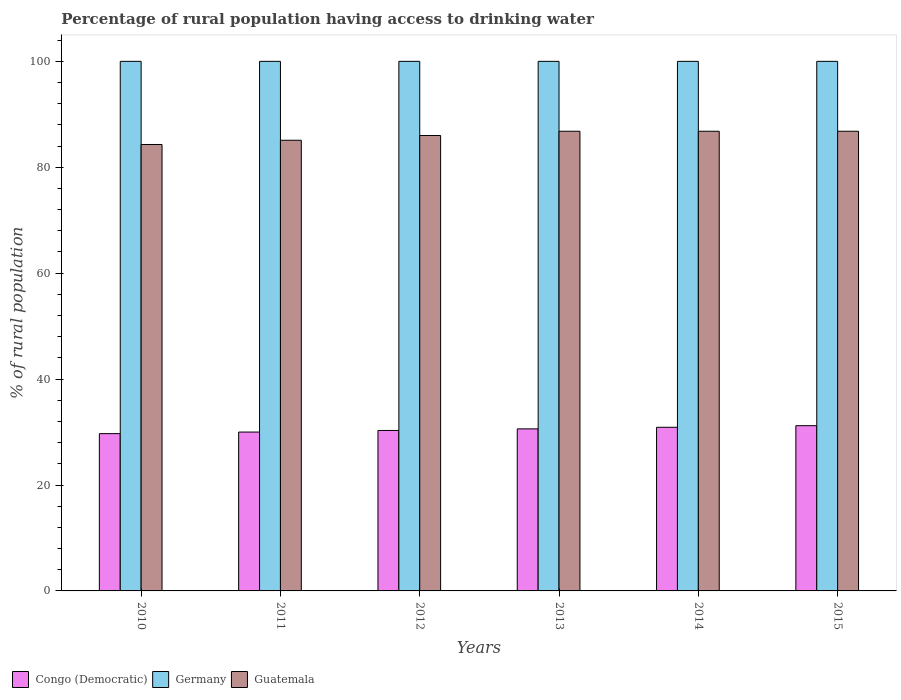How many groups of bars are there?
Your answer should be compact. 6. How many bars are there on the 5th tick from the left?
Keep it short and to the point. 3. In how many cases, is the number of bars for a given year not equal to the number of legend labels?
Keep it short and to the point. 0. Across all years, what is the maximum percentage of rural population having access to drinking water in Guatemala?
Offer a terse response. 86.8. Across all years, what is the minimum percentage of rural population having access to drinking water in Congo (Democratic)?
Give a very brief answer. 29.7. In which year was the percentage of rural population having access to drinking water in Germany maximum?
Your answer should be compact. 2010. What is the total percentage of rural population having access to drinking water in Germany in the graph?
Your answer should be compact. 600. What is the difference between the percentage of rural population having access to drinking water in Germany in 2014 and that in 2015?
Keep it short and to the point. 0. What is the difference between the percentage of rural population having access to drinking water in Guatemala in 2014 and the percentage of rural population having access to drinking water in Congo (Democratic) in 2012?
Your answer should be very brief. 56.5. What is the average percentage of rural population having access to drinking water in Guatemala per year?
Ensure brevity in your answer.  85.97. In the year 2012, what is the difference between the percentage of rural population having access to drinking water in Congo (Democratic) and percentage of rural population having access to drinking water in Germany?
Keep it short and to the point. -69.7. What is the ratio of the percentage of rural population having access to drinking water in Guatemala in 2011 to that in 2014?
Ensure brevity in your answer.  0.98. Is the percentage of rural population having access to drinking water in Germany in 2010 less than that in 2012?
Provide a succinct answer. No. Is the difference between the percentage of rural population having access to drinking water in Congo (Democratic) in 2013 and 2014 greater than the difference between the percentage of rural population having access to drinking water in Germany in 2013 and 2014?
Your response must be concise. No. What is the difference between the highest and the lowest percentage of rural population having access to drinking water in Congo (Democratic)?
Offer a terse response. 1.5. What does the 1st bar from the left in 2015 represents?
Give a very brief answer. Congo (Democratic). Is it the case that in every year, the sum of the percentage of rural population having access to drinking water in Germany and percentage of rural population having access to drinking water in Congo (Democratic) is greater than the percentage of rural population having access to drinking water in Guatemala?
Give a very brief answer. Yes. Are all the bars in the graph horizontal?
Give a very brief answer. No. What is the difference between two consecutive major ticks on the Y-axis?
Give a very brief answer. 20. Are the values on the major ticks of Y-axis written in scientific E-notation?
Provide a succinct answer. No. Where does the legend appear in the graph?
Provide a short and direct response. Bottom left. How many legend labels are there?
Ensure brevity in your answer.  3. What is the title of the graph?
Your answer should be very brief. Percentage of rural population having access to drinking water. What is the label or title of the X-axis?
Offer a terse response. Years. What is the label or title of the Y-axis?
Offer a very short reply. % of rural population. What is the % of rural population of Congo (Democratic) in 2010?
Your answer should be compact. 29.7. What is the % of rural population in Guatemala in 2010?
Ensure brevity in your answer.  84.3. What is the % of rural population of Germany in 2011?
Ensure brevity in your answer.  100. What is the % of rural population in Guatemala in 2011?
Give a very brief answer. 85.1. What is the % of rural population in Congo (Democratic) in 2012?
Ensure brevity in your answer.  30.3. What is the % of rural population of Germany in 2012?
Your answer should be very brief. 100. What is the % of rural population of Congo (Democratic) in 2013?
Your response must be concise. 30.6. What is the % of rural population of Germany in 2013?
Provide a short and direct response. 100. What is the % of rural population in Guatemala in 2013?
Provide a succinct answer. 86.8. What is the % of rural population of Congo (Democratic) in 2014?
Provide a succinct answer. 30.9. What is the % of rural population of Germany in 2014?
Offer a terse response. 100. What is the % of rural population of Guatemala in 2014?
Provide a succinct answer. 86.8. What is the % of rural population in Congo (Democratic) in 2015?
Offer a terse response. 31.2. What is the % of rural population of Guatemala in 2015?
Your answer should be very brief. 86.8. Across all years, what is the maximum % of rural population of Congo (Democratic)?
Your response must be concise. 31.2. Across all years, what is the maximum % of rural population of Guatemala?
Provide a short and direct response. 86.8. Across all years, what is the minimum % of rural population of Congo (Democratic)?
Offer a very short reply. 29.7. Across all years, what is the minimum % of rural population of Guatemala?
Your response must be concise. 84.3. What is the total % of rural population in Congo (Democratic) in the graph?
Offer a terse response. 182.7. What is the total % of rural population of Germany in the graph?
Provide a short and direct response. 600. What is the total % of rural population of Guatemala in the graph?
Keep it short and to the point. 515.8. What is the difference between the % of rural population of Germany in 2010 and that in 2011?
Your response must be concise. 0. What is the difference between the % of rural population of Congo (Democratic) in 2010 and that in 2012?
Keep it short and to the point. -0.6. What is the difference between the % of rural population in Germany in 2010 and that in 2012?
Provide a succinct answer. 0. What is the difference between the % of rural population in Guatemala in 2010 and that in 2012?
Your response must be concise. -1.7. What is the difference between the % of rural population of Congo (Democratic) in 2010 and that in 2013?
Provide a succinct answer. -0.9. What is the difference between the % of rural population of Guatemala in 2010 and that in 2013?
Give a very brief answer. -2.5. What is the difference between the % of rural population of Congo (Democratic) in 2010 and that in 2014?
Provide a short and direct response. -1.2. What is the difference between the % of rural population of Germany in 2010 and that in 2014?
Your answer should be compact. 0. What is the difference between the % of rural population in Guatemala in 2010 and that in 2014?
Offer a terse response. -2.5. What is the difference between the % of rural population in Congo (Democratic) in 2010 and that in 2015?
Your response must be concise. -1.5. What is the difference between the % of rural population in Germany in 2011 and that in 2012?
Provide a succinct answer. 0. What is the difference between the % of rural population of Congo (Democratic) in 2011 and that in 2013?
Give a very brief answer. -0.6. What is the difference between the % of rural population in Germany in 2011 and that in 2013?
Your response must be concise. 0. What is the difference between the % of rural population of Guatemala in 2011 and that in 2013?
Your answer should be very brief. -1.7. What is the difference between the % of rural population of Congo (Democratic) in 2011 and that in 2014?
Make the answer very short. -0.9. What is the difference between the % of rural population in Germany in 2011 and that in 2014?
Offer a very short reply. 0. What is the difference between the % of rural population in Guatemala in 2011 and that in 2014?
Provide a short and direct response. -1.7. What is the difference between the % of rural population in Congo (Democratic) in 2012 and that in 2013?
Your answer should be compact. -0.3. What is the difference between the % of rural population of Germany in 2012 and that in 2013?
Give a very brief answer. 0. What is the difference between the % of rural population in Germany in 2012 and that in 2014?
Provide a short and direct response. 0. What is the difference between the % of rural population of Congo (Democratic) in 2012 and that in 2015?
Your response must be concise. -0.9. What is the difference between the % of rural population of Germany in 2012 and that in 2015?
Keep it short and to the point. 0. What is the difference between the % of rural population of Guatemala in 2012 and that in 2015?
Make the answer very short. -0.8. What is the difference between the % of rural population of Congo (Democratic) in 2013 and that in 2014?
Your response must be concise. -0.3. What is the difference between the % of rural population of Germany in 2013 and that in 2014?
Provide a short and direct response. 0. What is the difference between the % of rural population in Guatemala in 2013 and that in 2014?
Your response must be concise. 0. What is the difference between the % of rural population of Germany in 2013 and that in 2015?
Ensure brevity in your answer.  0. What is the difference between the % of rural population of Guatemala in 2013 and that in 2015?
Provide a succinct answer. 0. What is the difference between the % of rural population in Congo (Democratic) in 2014 and that in 2015?
Provide a short and direct response. -0.3. What is the difference between the % of rural population of Guatemala in 2014 and that in 2015?
Make the answer very short. 0. What is the difference between the % of rural population of Congo (Democratic) in 2010 and the % of rural population of Germany in 2011?
Offer a terse response. -70.3. What is the difference between the % of rural population in Congo (Democratic) in 2010 and the % of rural population in Guatemala in 2011?
Keep it short and to the point. -55.4. What is the difference between the % of rural population in Germany in 2010 and the % of rural population in Guatemala in 2011?
Your response must be concise. 14.9. What is the difference between the % of rural population of Congo (Democratic) in 2010 and the % of rural population of Germany in 2012?
Your answer should be compact. -70.3. What is the difference between the % of rural population in Congo (Democratic) in 2010 and the % of rural population in Guatemala in 2012?
Ensure brevity in your answer.  -56.3. What is the difference between the % of rural population of Germany in 2010 and the % of rural population of Guatemala in 2012?
Offer a terse response. 14. What is the difference between the % of rural population in Congo (Democratic) in 2010 and the % of rural population in Germany in 2013?
Make the answer very short. -70.3. What is the difference between the % of rural population in Congo (Democratic) in 2010 and the % of rural population in Guatemala in 2013?
Your response must be concise. -57.1. What is the difference between the % of rural population in Congo (Democratic) in 2010 and the % of rural population in Germany in 2014?
Give a very brief answer. -70.3. What is the difference between the % of rural population in Congo (Democratic) in 2010 and the % of rural population in Guatemala in 2014?
Your answer should be compact. -57.1. What is the difference between the % of rural population in Germany in 2010 and the % of rural population in Guatemala in 2014?
Offer a terse response. 13.2. What is the difference between the % of rural population of Congo (Democratic) in 2010 and the % of rural population of Germany in 2015?
Your response must be concise. -70.3. What is the difference between the % of rural population of Congo (Democratic) in 2010 and the % of rural population of Guatemala in 2015?
Your answer should be very brief. -57.1. What is the difference between the % of rural population in Congo (Democratic) in 2011 and the % of rural population in Germany in 2012?
Keep it short and to the point. -70. What is the difference between the % of rural population in Congo (Democratic) in 2011 and the % of rural population in Guatemala in 2012?
Your answer should be compact. -56. What is the difference between the % of rural population of Germany in 2011 and the % of rural population of Guatemala in 2012?
Keep it short and to the point. 14. What is the difference between the % of rural population in Congo (Democratic) in 2011 and the % of rural population in Germany in 2013?
Provide a succinct answer. -70. What is the difference between the % of rural population of Congo (Democratic) in 2011 and the % of rural population of Guatemala in 2013?
Provide a short and direct response. -56.8. What is the difference between the % of rural population in Germany in 2011 and the % of rural population in Guatemala in 2013?
Your answer should be very brief. 13.2. What is the difference between the % of rural population of Congo (Democratic) in 2011 and the % of rural population of Germany in 2014?
Ensure brevity in your answer.  -70. What is the difference between the % of rural population in Congo (Democratic) in 2011 and the % of rural population in Guatemala in 2014?
Provide a succinct answer. -56.8. What is the difference between the % of rural population of Germany in 2011 and the % of rural population of Guatemala in 2014?
Offer a terse response. 13.2. What is the difference between the % of rural population in Congo (Democratic) in 2011 and the % of rural population in Germany in 2015?
Your answer should be compact. -70. What is the difference between the % of rural population of Congo (Democratic) in 2011 and the % of rural population of Guatemala in 2015?
Your answer should be very brief. -56.8. What is the difference between the % of rural population of Congo (Democratic) in 2012 and the % of rural population of Germany in 2013?
Your response must be concise. -69.7. What is the difference between the % of rural population of Congo (Democratic) in 2012 and the % of rural population of Guatemala in 2013?
Offer a terse response. -56.5. What is the difference between the % of rural population in Congo (Democratic) in 2012 and the % of rural population in Germany in 2014?
Your answer should be compact. -69.7. What is the difference between the % of rural population in Congo (Democratic) in 2012 and the % of rural population in Guatemala in 2014?
Your answer should be compact. -56.5. What is the difference between the % of rural population of Congo (Democratic) in 2012 and the % of rural population of Germany in 2015?
Your answer should be very brief. -69.7. What is the difference between the % of rural population of Congo (Democratic) in 2012 and the % of rural population of Guatemala in 2015?
Offer a terse response. -56.5. What is the difference between the % of rural population in Congo (Democratic) in 2013 and the % of rural population in Germany in 2014?
Give a very brief answer. -69.4. What is the difference between the % of rural population in Congo (Democratic) in 2013 and the % of rural population in Guatemala in 2014?
Make the answer very short. -56.2. What is the difference between the % of rural population of Germany in 2013 and the % of rural population of Guatemala in 2014?
Ensure brevity in your answer.  13.2. What is the difference between the % of rural population of Congo (Democratic) in 2013 and the % of rural population of Germany in 2015?
Keep it short and to the point. -69.4. What is the difference between the % of rural population of Congo (Democratic) in 2013 and the % of rural population of Guatemala in 2015?
Ensure brevity in your answer.  -56.2. What is the difference between the % of rural population of Germany in 2013 and the % of rural population of Guatemala in 2015?
Keep it short and to the point. 13.2. What is the difference between the % of rural population of Congo (Democratic) in 2014 and the % of rural population of Germany in 2015?
Provide a succinct answer. -69.1. What is the difference between the % of rural population in Congo (Democratic) in 2014 and the % of rural population in Guatemala in 2015?
Keep it short and to the point. -55.9. What is the average % of rural population of Congo (Democratic) per year?
Make the answer very short. 30.45. What is the average % of rural population of Guatemala per year?
Your answer should be very brief. 85.97. In the year 2010, what is the difference between the % of rural population in Congo (Democratic) and % of rural population in Germany?
Provide a succinct answer. -70.3. In the year 2010, what is the difference between the % of rural population of Congo (Democratic) and % of rural population of Guatemala?
Give a very brief answer. -54.6. In the year 2010, what is the difference between the % of rural population of Germany and % of rural population of Guatemala?
Offer a very short reply. 15.7. In the year 2011, what is the difference between the % of rural population in Congo (Democratic) and % of rural population in Germany?
Give a very brief answer. -70. In the year 2011, what is the difference between the % of rural population in Congo (Democratic) and % of rural population in Guatemala?
Provide a short and direct response. -55.1. In the year 2011, what is the difference between the % of rural population in Germany and % of rural population in Guatemala?
Offer a very short reply. 14.9. In the year 2012, what is the difference between the % of rural population in Congo (Democratic) and % of rural population in Germany?
Provide a succinct answer. -69.7. In the year 2012, what is the difference between the % of rural population of Congo (Democratic) and % of rural population of Guatemala?
Keep it short and to the point. -55.7. In the year 2012, what is the difference between the % of rural population in Germany and % of rural population in Guatemala?
Give a very brief answer. 14. In the year 2013, what is the difference between the % of rural population of Congo (Democratic) and % of rural population of Germany?
Offer a very short reply. -69.4. In the year 2013, what is the difference between the % of rural population in Congo (Democratic) and % of rural population in Guatemala?
Your answer should be very brief. -56.2. In the year 2014, what is the difference between the % of rural population of Congo (Democratic) and % of rural population of Germany?
Offer a terse response. -69.1. In the year 2014, what is the difference between the % of rural population in Congo (Democratic) and % of rural population in Guatemala?
Provide a short and direct response. -55.9. In the year 2015, what is the difference between the % of rural population of Congo (Democratic) and % of rural population of Germany?
Your response must be concise. -68.8. In the year 2015, what is the difference between the % of rural population in Congo (Democratic) and % of rural population in Guatemala?
Your answer should be compact. -55.6. What is the ratio of the % of rural population of Guatemala in 2010 to that in 2011?
Your answer should be very brief. 0.99. What is the ratio of the % of rural population in Congo (Democratic) in 2010 to that in 2012?
Make the answer very short. 0.98. What is the ratio of the % of rural population of Guatemala in 2010 to that in 2012?
Give a very brief answer. 0.98. What is the ratio of the % of rural population of Congo (Democratic) in 2010 to that in 2013?
Your response must be concise. 0.97. What is the ratio of the % of rural population of Guatemala in 2010 to that in 2013?
Your response must be concise. 0.97. What is the ratio of the % of rural population in Congo (Democratic) in 2010 to that in 2014?
Keep it short and to the point. 0.96. What is the ratio of the % of rural population of Guatemala in 2010 to that in 2014?
Ensure brevity in your answer.  0.97. What is the ratio of the % of rural population of Congo (Democratic) in 2010 to that in 2015?
Make the answer very short. 0.95. What is the ratio of the % of rural population in Germany in 2010 to that in 2015?
Your response must be concise. 1. What is the ratio of the % of rural population in Guatemala in 2010 to that in 2015?
Provide a succinct answer. 0.97. What is the ratio of the % of rural population in Guatemala in 2011 to that in 2012?
Your answer should be compact. 0.99. What is the ratio of the % of rural population of Congo (Democratic) in 2011 to that in 2013?
Your response must be concise. 0.98. What is the ratio of the % of rural population of Guatemala in 2011 to that in 2013?
Your answer should be compact. 0.98. What is the ratio of the % of rural population in Congo (Democratic) in 2011 to that in 2014?
Your response must be concise. 0.97. What is the ratio of the % of rural population of Germany in 2011 to that in 2014?
Keep it short and to the point. 1. What is the ratio of the % of rural population in Guatemala in 2011 to that in 2014?
Offer a very short reply. 0.98. What is the ratio of the % of rural population in Congo (Democratic) in 2011 to that in 2015?
Make the answer very short. 0.96. What is the ratio of the % of rural population of Germany in 2011 to that in 2015?
Keep it short and to the point. 1. What is the ratio of the % of rural population of Guatemala in 2011 to that in 2015?
Offer a terse response. 0.98. What is the ratio of the % of rural population in Congo (Democratic) in 2012 to that in 2013?
Offer a terse response. 0.99. What is the ratio of the % of rural population in Germany in 2012 to that in 2013?
Give a very brief answer. 1. What is the ratio of the % of rural population in Guatemala in 2012 to that in 2013?
Your answer should be very brief. 0.99. What is the ratio of the % of rural population of Congo (Democratic) in 2012 to that in 2014?
Offer a terse response. 0.98. What is the ratio of the % of rural population in Congo (Democratic) in 2012 to that in 2015?
Give a very brief answer. 0.97. What is the ratio of the % of rural population of Guatemala in 2012 to that in 2015?
Keep it short and to the point. 0.99. What is the ratio of the % of rural population of Congo (Democratic) in 2013 to that in 2014?
Make the answer very short. 0.99. What is the ratio of the % of rural population of Germany in 2013 to that in 2014?
Offer a very short reply. 1. What is the ratio of the % of rural population of Congo (Democratic) in 2013 to that in 2015?
Offer a very short reply. 0.98. What is the ratio of the % of rural population in Guatemala in 2013 to that in 2015?
Provide a short and direct response. 1. What is the ratio of the % of rural population of Congo (Democratic) in 2014 to that in 2015?
Your answer should be very brief. 0.99. What is the ratio of the % of rural population in Germany in 2014 to that in 2015?
Give a very brief answer. 1. What is the difference between the highest and the second highest % of rural population of Congo (Democratic)?
Provide a short and direct response. 0.3. What is the difference between the highest and the second highest % of rural population in Germany?
Your answer should be compact. 0. What is the difference between the highest and the second highest % of rural population in Guatemala?
Offer a very short reply. 0. 